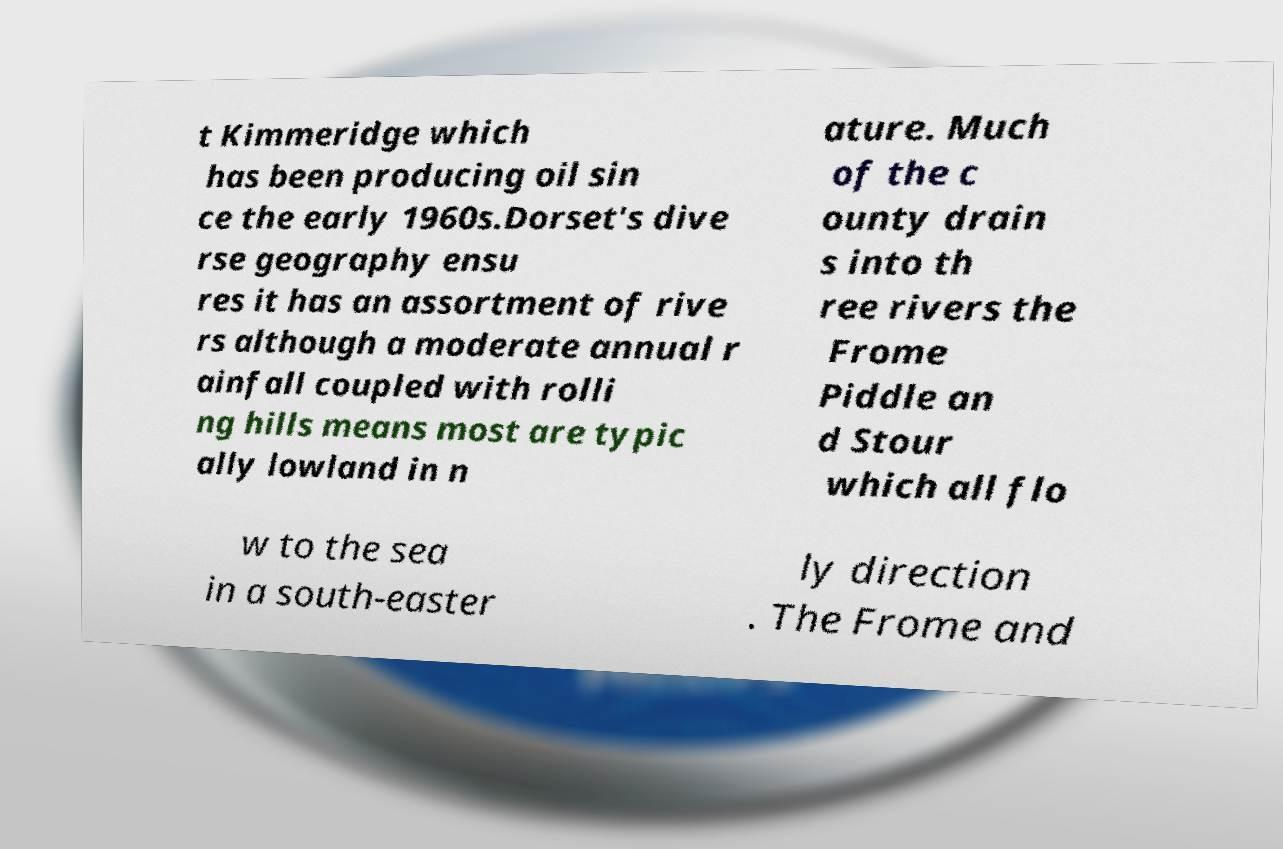Could you extract and type out the text from this image? t Kimmeridge which has been producing oil sin ce the early 1960s.Dorset's dive rse geography ensu res it has an assortment of rive rs although a moderate annual r ainfall coupled with rolli ng hills means most are typic ally lowland in n ature. Much of the c ounty drain s into th ree rivers the Frome Piddle an d Stour which all flo w to the sea in a south-easter ly direction . The Frome and 